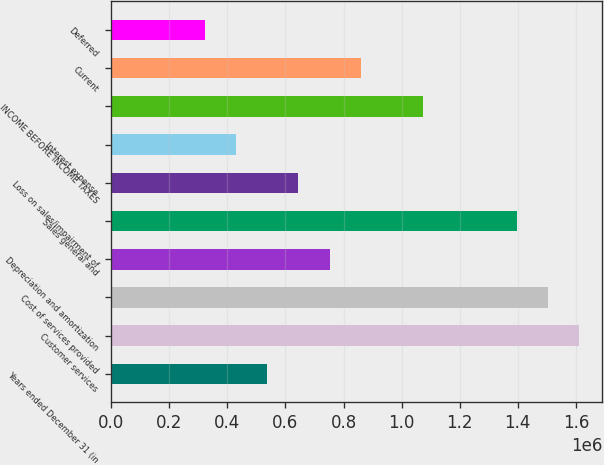<chart> <loc_0><loc_0><loc_500><loc_500><bar_chart><fcel>Years ended December 31 (in<fcel>Customer services<fcel>Cost of services provided<fcel>Depreciation and amortization<fcel>Sales general and<fcel>Loss on sales/impairment of<fcel>Interest expense<fcel>INCOME BEFORE INCOME TAXES<fcel>Current<fcel>Deferred<nl><fcel>536979<fcel>1.61094e+06<fcel>1.50354e+06<fcel>751771<fcel>1.39615e+06<fcel>644375<fcel>429583<fcel>1.07396e+06<fcel>859166<fcel>322188<nl></chart> 